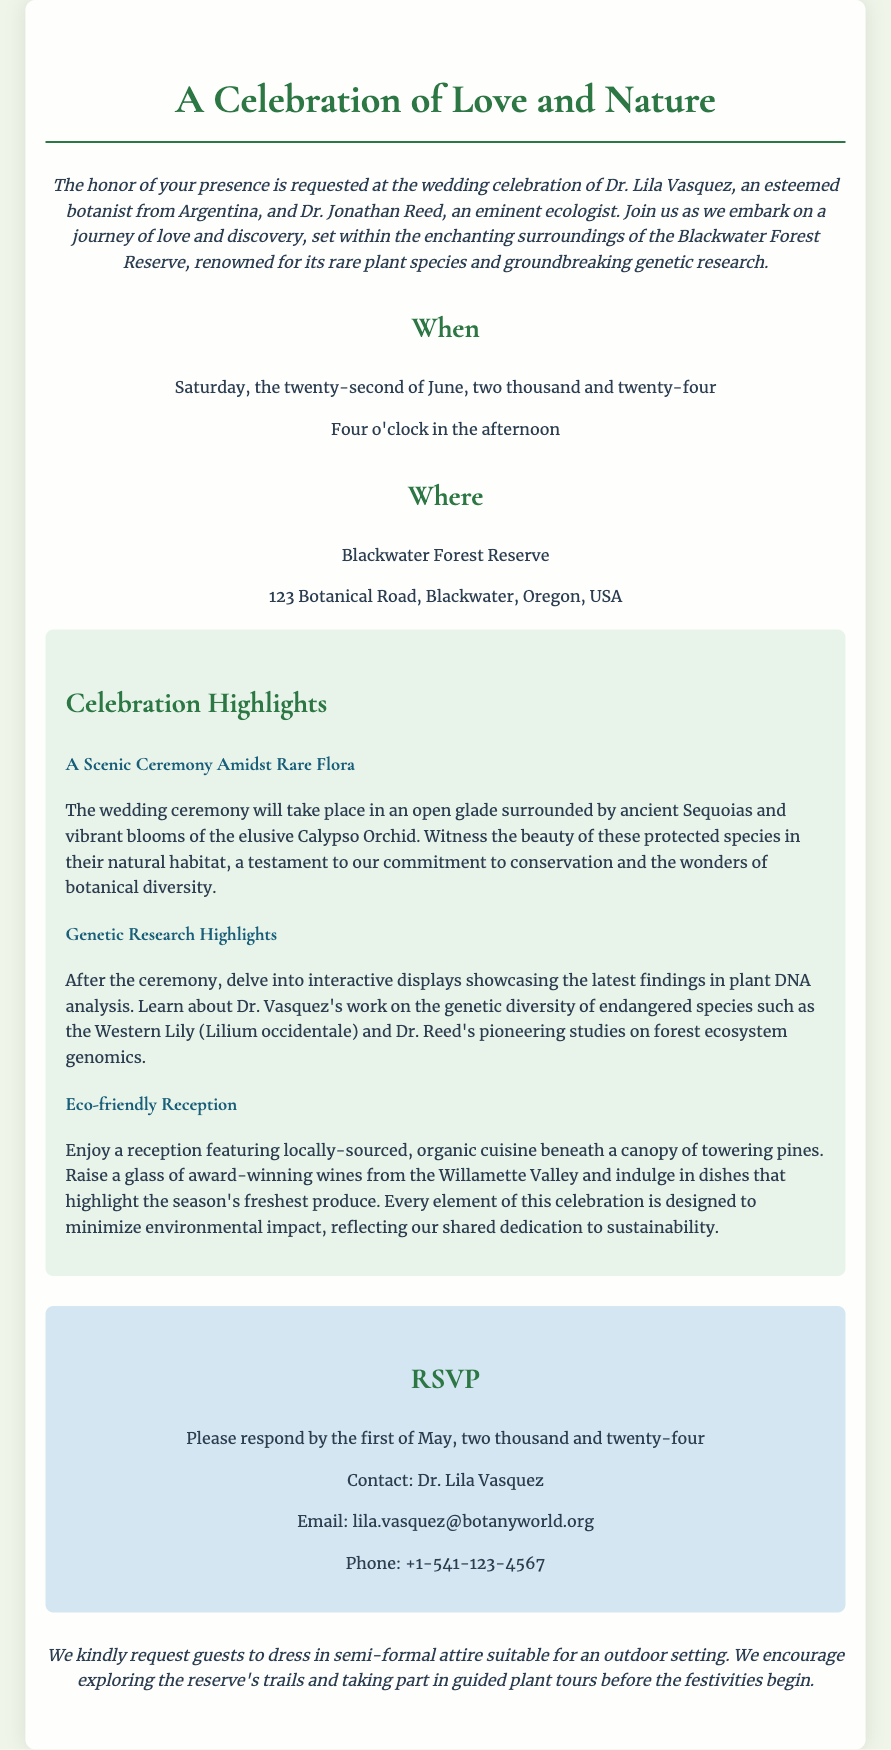What is the date of the wedding? The wedding is scheduled for Saturday, the twenty-second of June, two thousand and twenty-four.
Answer: June 22, 2024 Who are the couple getting married? The wedding celebration is for Dr. Lila Vasquez and Dr. Jonathan Reed.
Answer: Dr. Lila Vasquez and Dr. Jonathan Reed What is the location of the wedding? The wedding will take place at Blackwater Forest Reserve, 123 Botanical Road, Blackwater, Oregon, USA.
Answer: Blackwater Forest Reserve What will be served at the reception? The reception will feature locally-sourced, organic cuisine and award-winning wines.
Answer: Organic cuisine and award-winning wines What is one of the rare plant species mentioned in the ceremony? The ceremony highlights the vibrant blooms of the elusive Calypso Orchid.
Answer: Calypso Orchid What is the RSVP deadline? Guests are requested to respond by the first of May, two thousand and twenty-four.
Answer: May 1, 2024 What type of attire is requested for guests? Guests are kindly requested to dress in semi-formal attire suitable for an outdoor setting.
Answer: Semi-formal attire What type of displays will be featured after the ceremony? There will be interactive displays showcasing the latest findings in plant DNA analysis.
Answer: Interactive displays What aspect of the celebration reflects dedication to sustainability? Every element of the celebration is designed to minimize environmental impact.
Answer: Minimize environmental impact 